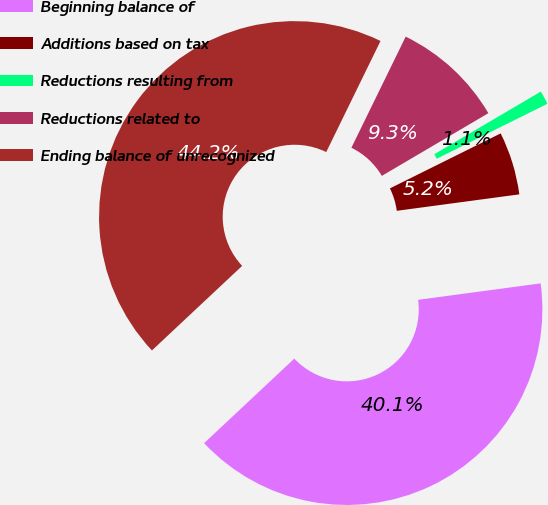Convert chart to OTSL. <chart><loc_0><loc_0><loc_500><loc_500><pie_chart><fcel>Beginning balance of<fcel>Additions based on tax<fcel>Reductions resulting from<fcel>Reductions related to<fcel>Ending balance of unrecognized<nl><fcel>40.14%<fcel>5.21%<fcel>1.13%<fcel>9.3%<fcel>44.22%<nl></chart> 